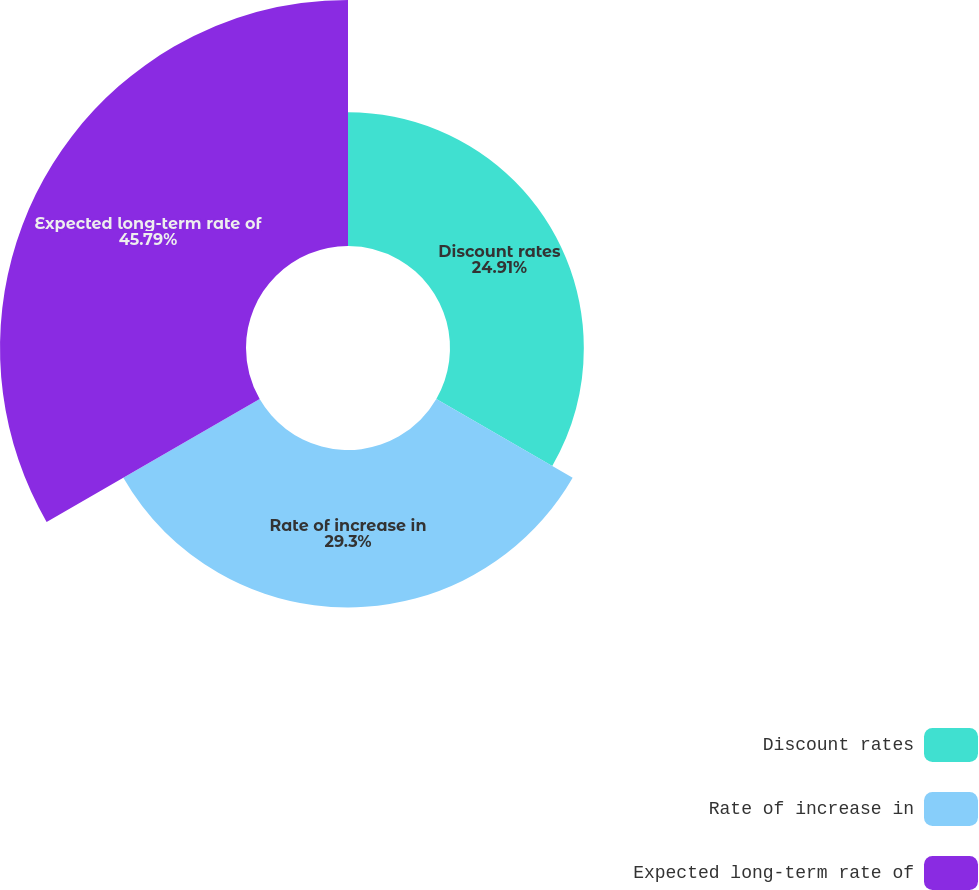Convert chart to OTSL. <chart><loc_0><loc_0><loc_500><loc_500><pie_chart><fcel>Discount rates<fcel>Rate of increase in<fcel>Expected long-term rate of<nl><fcel>24.91%<fcel>29.3%<fcel>45.79%<nl></chart> 